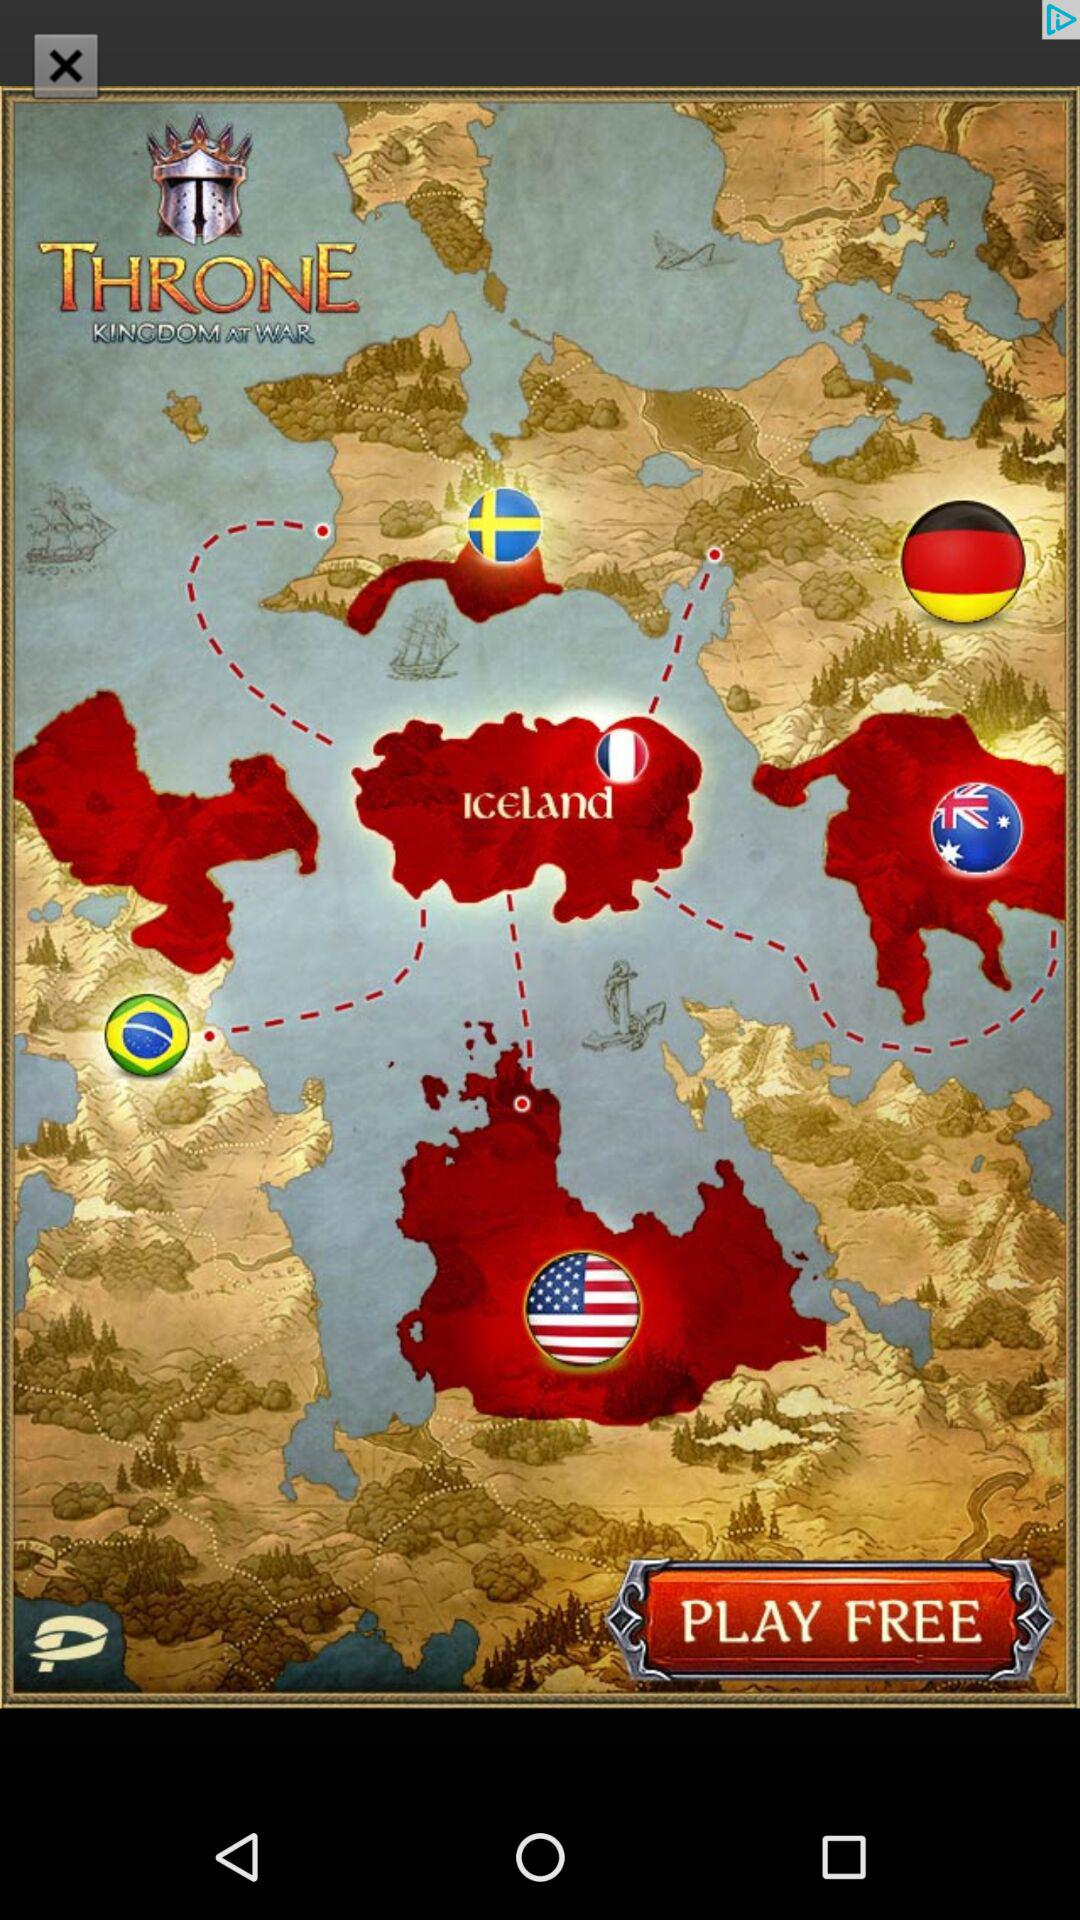How many flags are there on the map?
Answer the question using a single word or phrase. 6 